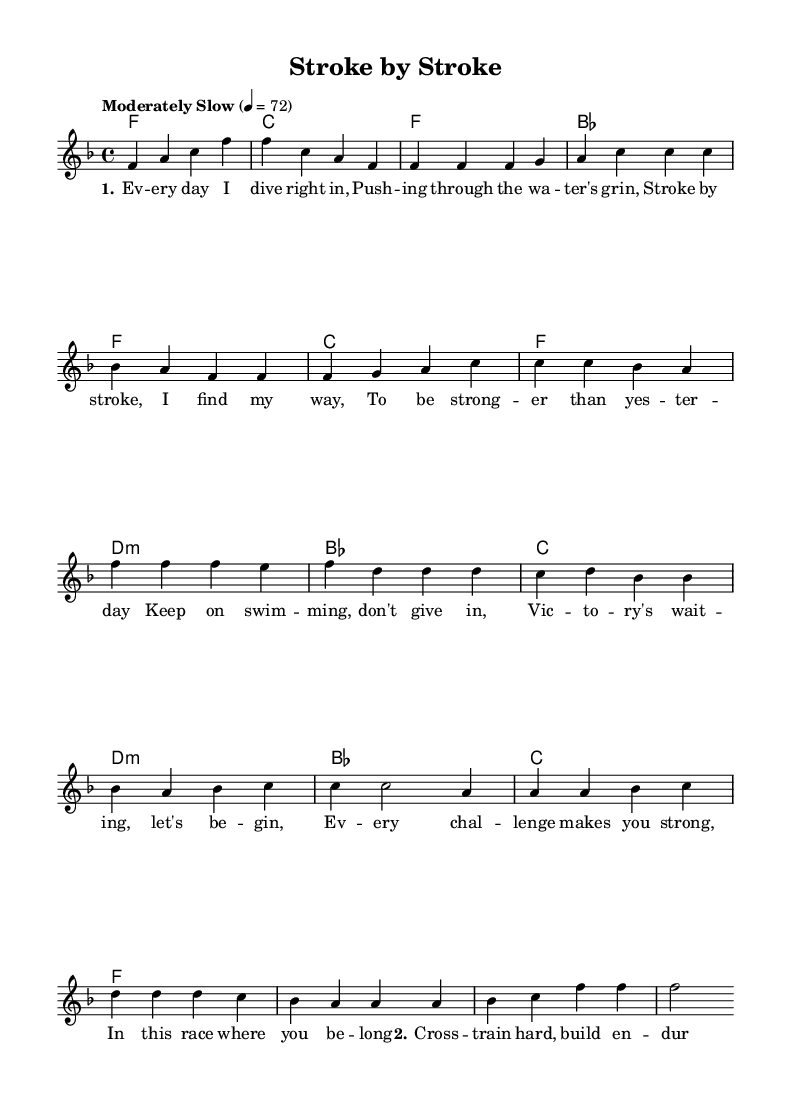What is the key signature of this music? The key signature is determined from the beginning of the piece. In the provided code, it states "\key f \major", indicating the key signature is F major, which has one flat (B flat).
Answer: F major What is the time signature of this music? The time signature can be found in the global settings of the code, where it specifies "\time 4/4". This indicates there are four beats in each measure, and a quarter note gets one beat.
Answer: 4/4 What is the tempo marking of this piece? The tempo is indicated in the global settings with the phrase "\tempo "Moderately Slow" 4 = 72". This means the piece is to be played at a moderately slow speed of 72 beats per minute.
Answer: Moderately Slow What are the first three notes of the melody? To find the first three notes, look at the initial part of the "melody" section. The first three notes are f, a, c.
Answer: f a c How many verses are there in the song? The song has two verses as indicated by the structure in the code. There is a second verse defined after the chorus, and it starts with "\verseTwo".
Answer: 2 What is the main theme of the lyrics in this piece? The lyrics focus on overcoming challenges and striving for strength and endurance, which can be deduced from the content of both verses and the chorus. The lyrics encourage persistence and overcoming difficulties.
Answer: Overcoming challenges What chord is used during the chorus? The chords used during the chorus part can be found in the "harmonies" section. The progression includes f, d minor, b flat, and c. The first chord in the chorus is f.
Answer: f 